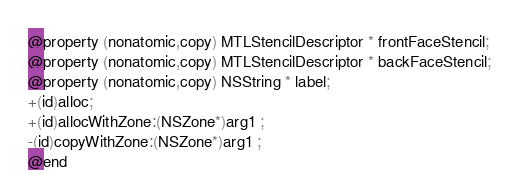<code> <loc_0><loc_0><loc_500><loc_500><_C_>@property (nonatomic,copy) MTLStencilDescriptor * frontFaceStencil; 
@property (nonatomic,copy) MTLStencilDescriptor * backFaceStencil; 
@property (nonatomic,copy) NSString * label; 
+(id)alloc;
+(id)allocWithZone:(NSZone*)arg1 ;
-(id)copyWithZone:(NSZone*)arg1 ;
@end

</code> 